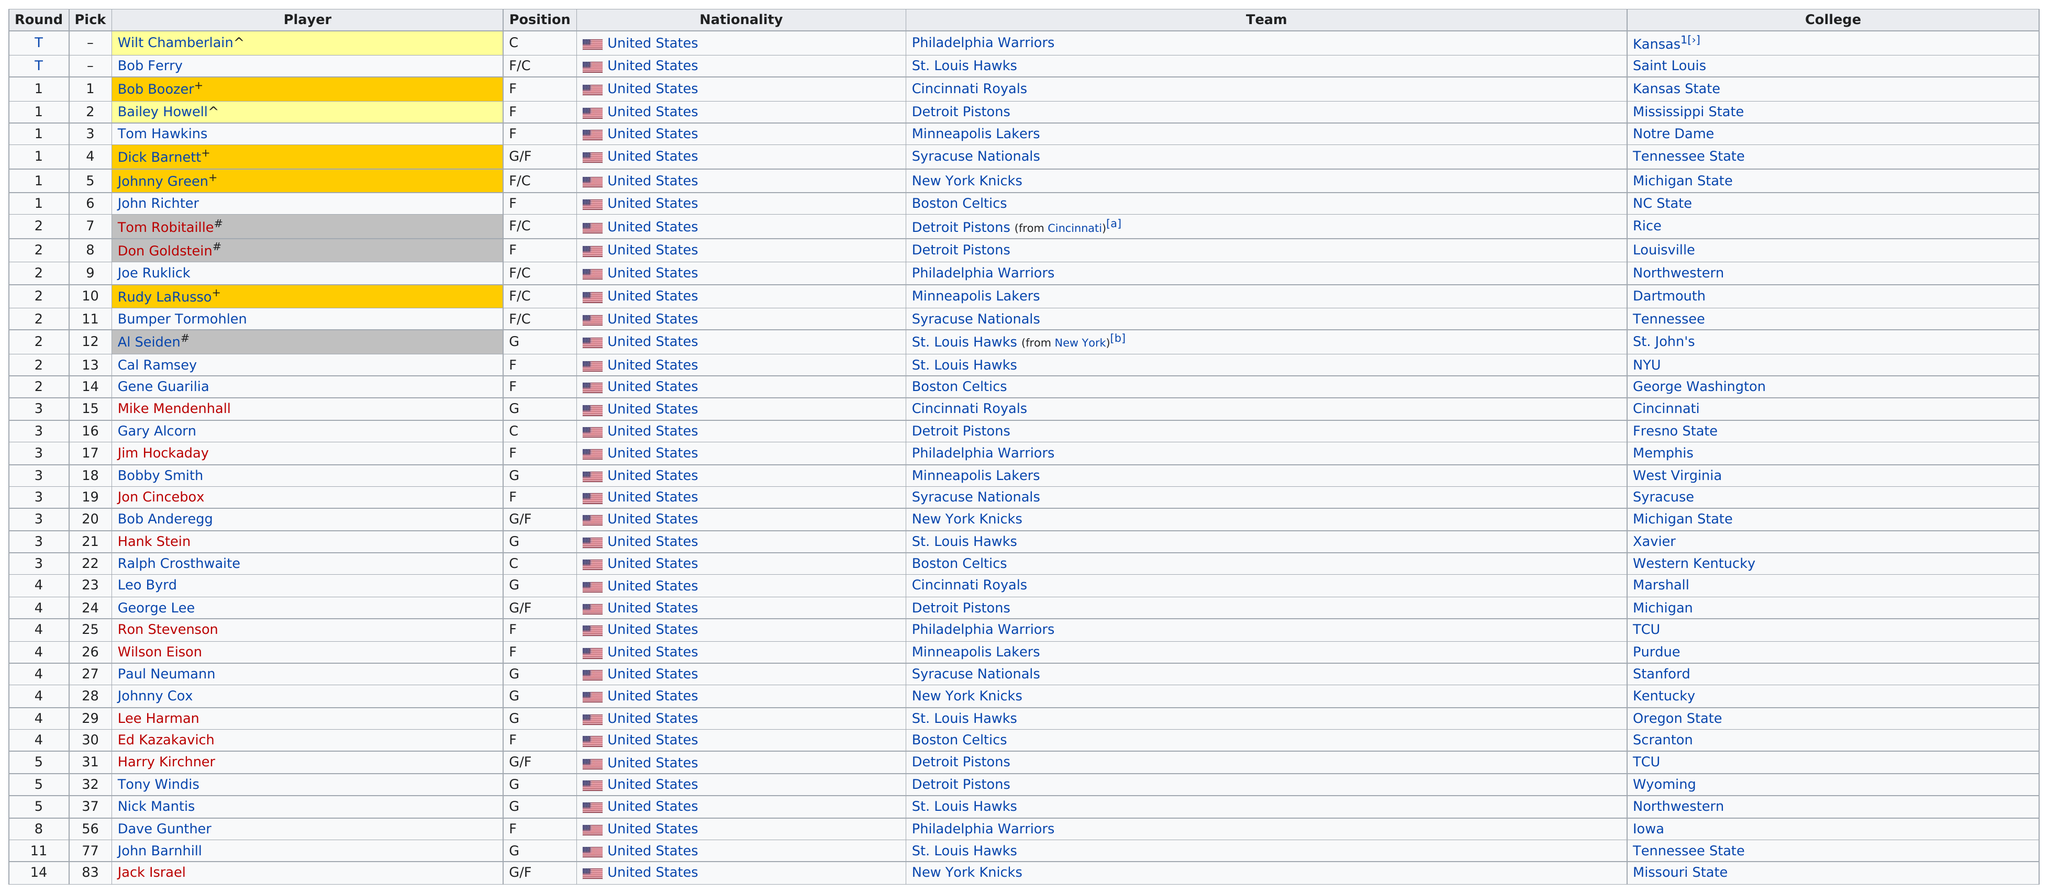Specify some key components in this picture. In the 2023 NBA Draft, the player who was selected as the fourth overall pick attended Tennessee State University. The Cincinnati Royals, Minneapolis Lakers, Syracuse Nationals, New York Knicks, and Boston Celtics had the most number of players with four. The St. Louis Hawks made seven picks in the draft. The previous pick attended college at Syracuse University, just like Bob Anderegg. The New York Knicks are preceded by a team called 'Hank Stein' in the order of team affiliations. 